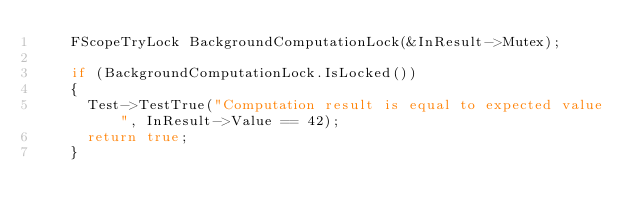Convert code to text. <code><loc_0><loc_0><loc_500><loc_500><_C++_>		FScopeTryLock BackgroundComputationLock(&InResult->Mutex);

		if (BackgroundComputationLock.IsLocked())
		{
			Test->TestTrue("Computation result is equal to expected value", InResult->Value == 42);
			return true;
		}
</code> 